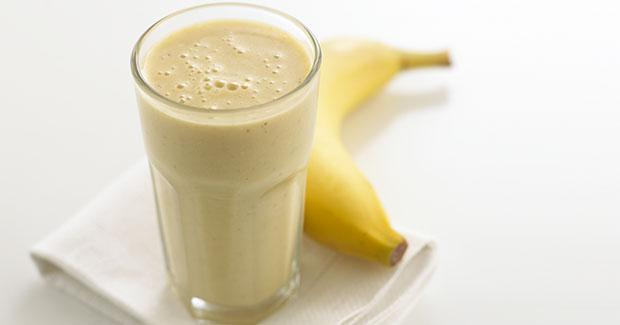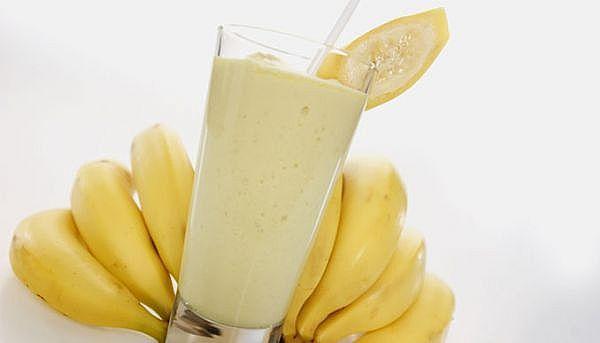The first image is the image on the left, the second image is the image on the right. Assess this claim about the two images: "The left image contains one smoothie with a small banana slice in the rim of its glass.". Correct or not? Answer yes or no. No. 